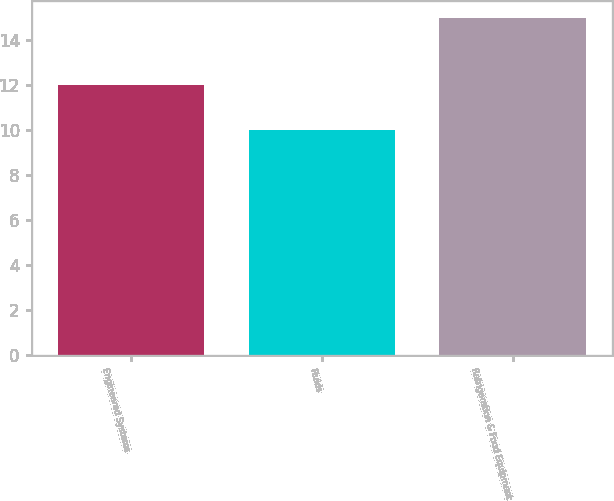Convert chart. <chart><loc_0><loc_0><loc_500><loc_500><bar_chart><fcel>Engineered Systems<fcel>Fluids<fcel>Refrigeration & Food Equipment<nl><fcel>12<fcel>10<fcel>15<nl></chart> 